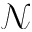<formula> <loc_0><loc_0><loc_500><loc_500>\mathcal { N }</formula> 